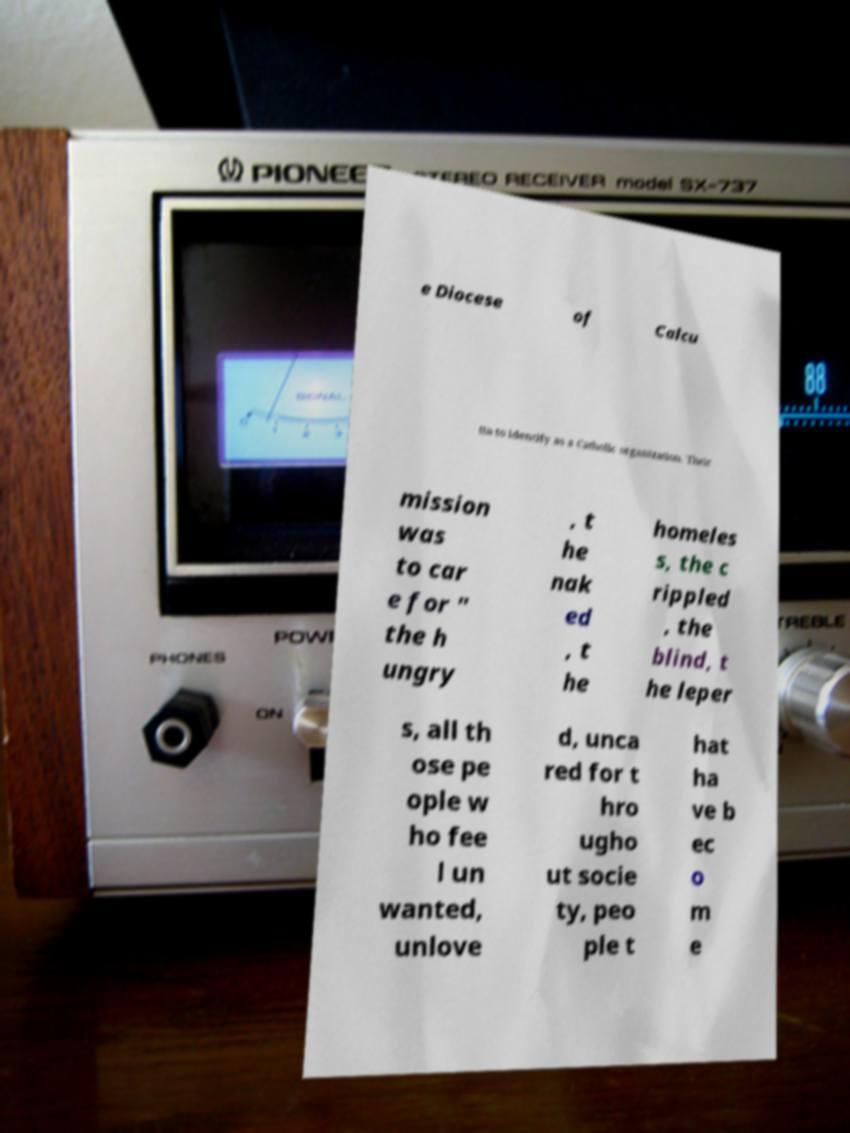I need the written content from this picture converted into text. Can you do that? e Diocese of Calcu tta to identify as a Catholic organization. Their mission was to car e for " the h ungry , t he nak ed , t he homeles s, the c rippled , the blind, t he leper s, all th ose pe ople w ho fee l un wanted, unlove d, unca red for t hro ugho ut socie ty, peo ple t hat ha ve b ec o m e 